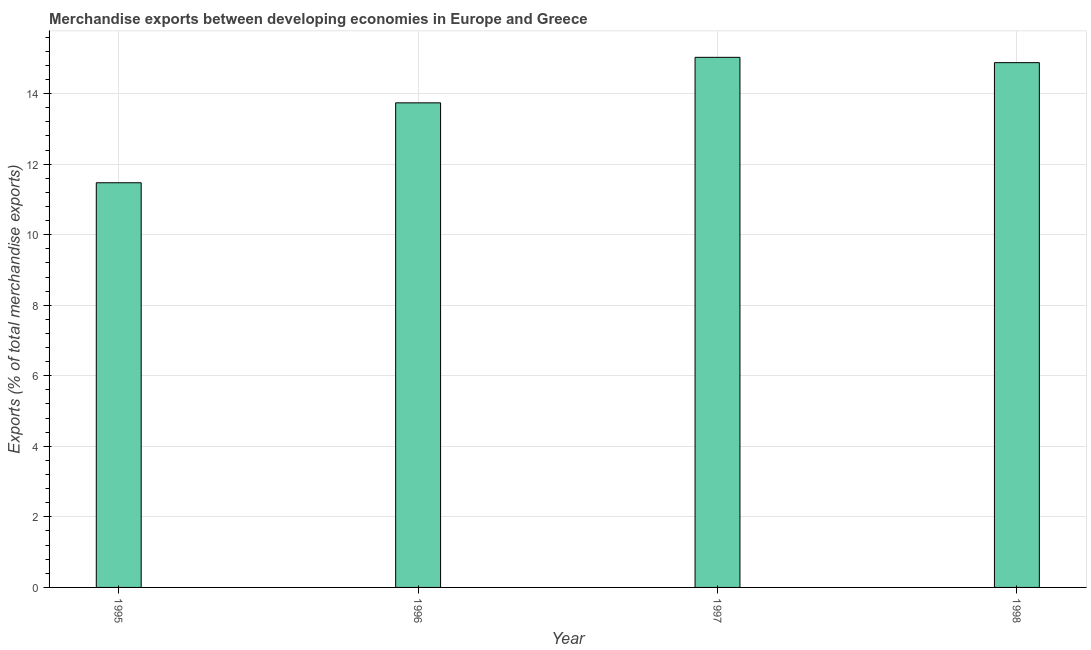Does the graph contain grids?
Ensure brevity in your answer.  Yes. What is the title of the graph?
Provide a short and direct response. Merchandise exports between developing economies in Europe and Greece. What is the label or title of the X-axis?
Your answer should be very brief. Year. What is the label or title of the Y-axis?
Offer a terse response. Exports (% of total merchandise exports). What is the merchandise exports in 1996?
Your answer should be compact. 13.74. Across all years, what is the maximum merchandise exports?
Keep it short and to the point. 15.03. Across all years, what is the minimum merchandise exports?
Provide a succinct answer. 11.47. What is the sum of the merchandise exports?
Your answer should be very brief. 55.11. What is the difference between the merchandise exports in 1995 and 1998?
Your answer should be compact. -3.4. What is the average merchandise exports per year?
Provide a succinct answer. 13.78. What is the median merchandise exports?
Provide a short and direct response. 14.31. Do a majority of the years between 1995 and 1997 (inclusive) have merchandise exports greater than 2.4 %?
Make the answer very short. Yes. What is the ratio of the merchandise exports in 1996 to that in 1997?
Your answer should be compact. 0.91. Is the difference between the merchandise exports in 1997 and 1998 greater than the difference between any two years?
Provide a short and direct response. No. What is the difference between the highest and the second highest merchandise exports?
Offer a terse response. 0.15. What is the difference between the highest and the lowest merchandise exports?
Provide a short and direct response. 3.56. In how many years, is the merchandise exports greater than the average merchandise exports taken over all years?
Keep it short and to the point. 2. How many bars are there?
Provide a short and direct response. 4. Are all the bars in the graph horizontal?
Offer a terse response. No. How many years are there in the graph?
Make the answer very short. 4. Are the values on the major ticks of Y-axis written in scientific E-notation?
Ensure brevity in your answer.  No. What is the Exports (% of total merchandise exports) in 1995?
Ensure brevity in your answer.  11.47. What is the Exports (% of total merchandise exports) in 1996?
Your answer should be very brief. 13.74. What is the Exports (% of total merchandise exports) in 1997?
Ensure brevity in your answer.  15.03. What is the Exports (% of total merchandise exports) of 1998?
Offer a terse response. 14.88. What is the difference between the Exports (% of total merchandise exports) in 1995 and 1996?
Offer a terse response. -2.27. What is the difference between the Exports (% of total merchandise exports) in 1995 and 1997?
Provide a short and direct response. -3.56. What is the difference between the Exports (% of total merchandise exports) in 1995 and 1998?
Provide a succinct answer. -3.4. What is the difference between the Exports (% of total merchandise exports) in 1996 and 1997?
Provide a short and direct response. -1.29. What is the difference between the Exports (% of total merchandise exports) in 1996 and 1998?
Offer a very short reply. -1.14. What is the difference between the Exports (% of total merchandise exports) in 1997 and 1998?
Ensure brevity in your answer.  0.15. What is the ratio of the Exports (% of total merchandise exports) in 1995 to that in 1996?
Your answer should be compact. 0.83. What is the ratio of the Exports (% of total merchandise exports) in 1995 to that in 1997?
Your response must be concise. 0.76. What is the ratio of the Exports (% of total merchandise exports) in 1995 to that in 1998?
Your response must be concise. 0.77. What is the ratio of the Exports (% of total merchandise exports) in 1996 to that in 1997?
Give a very brief answer. 0.91. What is the ratio of the Exports (% of total merchandise exports) in 1996 to that in 1998?
Provide a short and direct response. 0.92. 